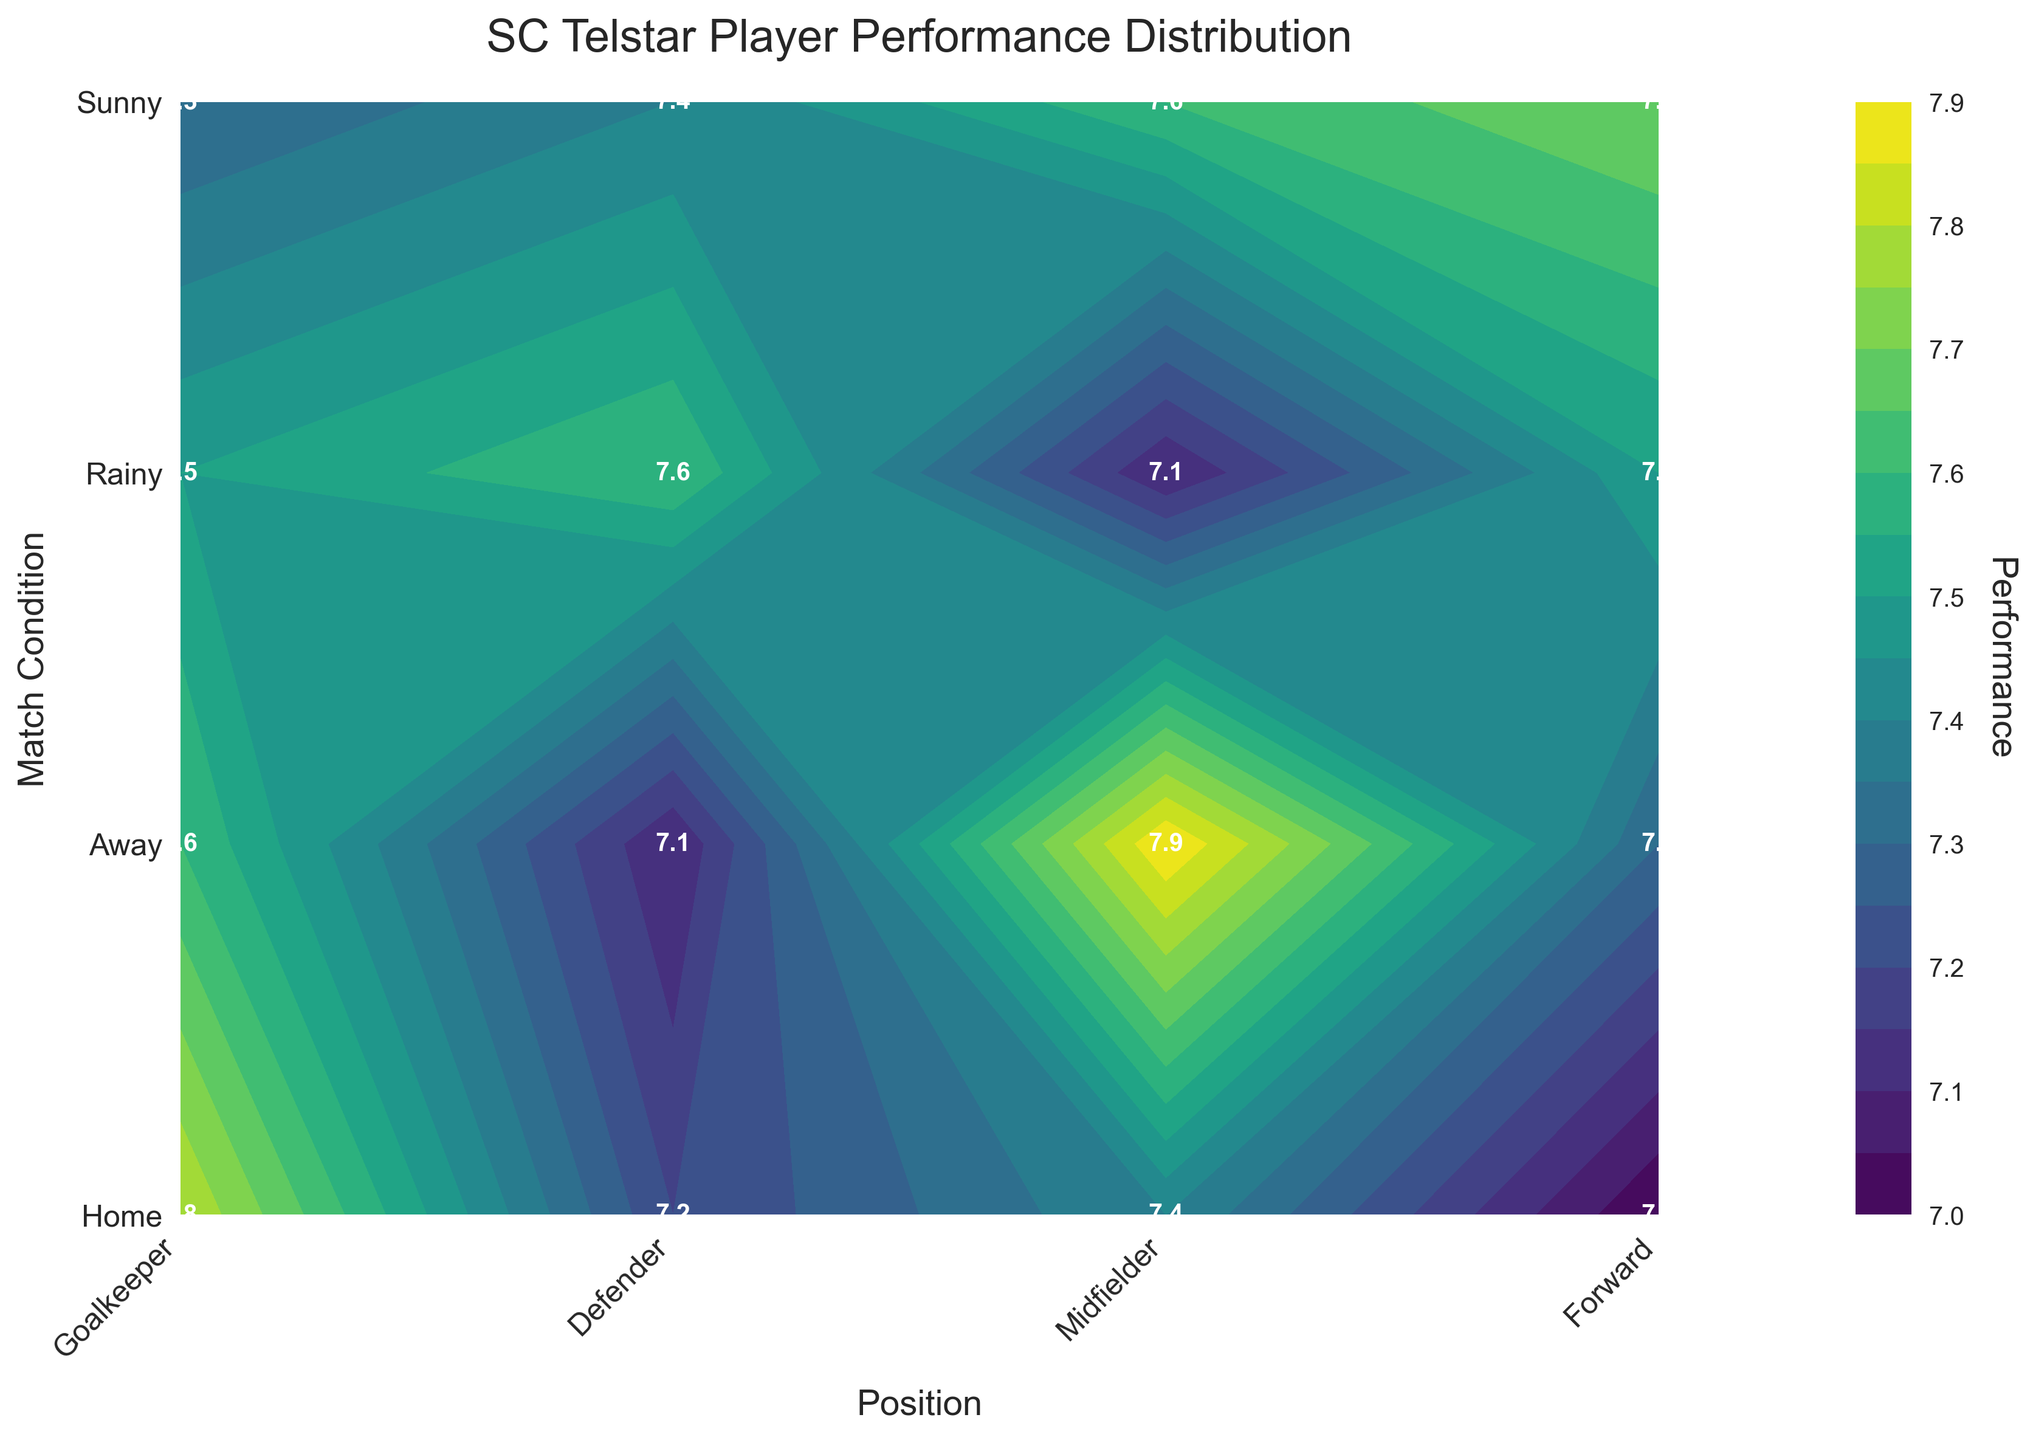What is the title of the figure? The title of the figure is usually located at the top of the plot. In this case, the title is directly above the plot.
Answer: SC Telstar Player Performance Distribution How many match conditions are shown on the Y-axis? By looking at the Y-axis, we can see four labeled ticks representing the conditions.
Answer: Four What is the highest recorded performance among the positions and match conditions? The highest performance value can be found by looking at the values labeled on the plot.
Answer: 7.9 Which position had the lowest performance in an "Away" match? Look at the performance values in the "Away" row for each position. The lowest value is among these.
Answer: Defender How does the performance of goalkeepers differ between "Home" and "Away" matches? Compare the performance values for goalkeepers in "Home" and "Away" conditions. The specific values are 7.8 for "Home" and 7.2 for "Away".
Answer: 0.6 lower in "Away" matches Which position has the most consistent performance across all match conditions? To find consistency, look at the range of performance values for each position. The position with the smallest range of values is the most consistent.
Answer: Goalkeeper Rank the positions from highest to lowest based on their average performance in "Sunny" match conditions. Calculate the average performance for each position under "Sunny" conditions by inspecting the labeled values: Forward (7.7), Goalkeeper (7.6), Midfielder (7.4), Defender (7.5). Rank them accordingly.
Answer: Forward, Goalkeeper, Defender, Midfielder Which position shows the greatest improvement from "Rainy" to "Sunny" match conditions? Calculate the difference in performance for each position between "Rainy" and "Sunny" conditions, and identify the position with the highest positive difference.
Answer: Defender What is the average performance of all positions under "Home" conditions? Add the performance values for all positions under "Home" conditions (7.8, 7.4, 7.6, 7.9) and divide by the number of positions. The computation is: (7.8 + 7.4 + 7.6 + 7.9) / 4 = 7.675
Answer: 7.7 Which match condition generally results in better performances for SC Telstar players? Compare the average performance values for all match conditions. Sum the performance values under each condition and divide by the number of positions.
Answer: Home 